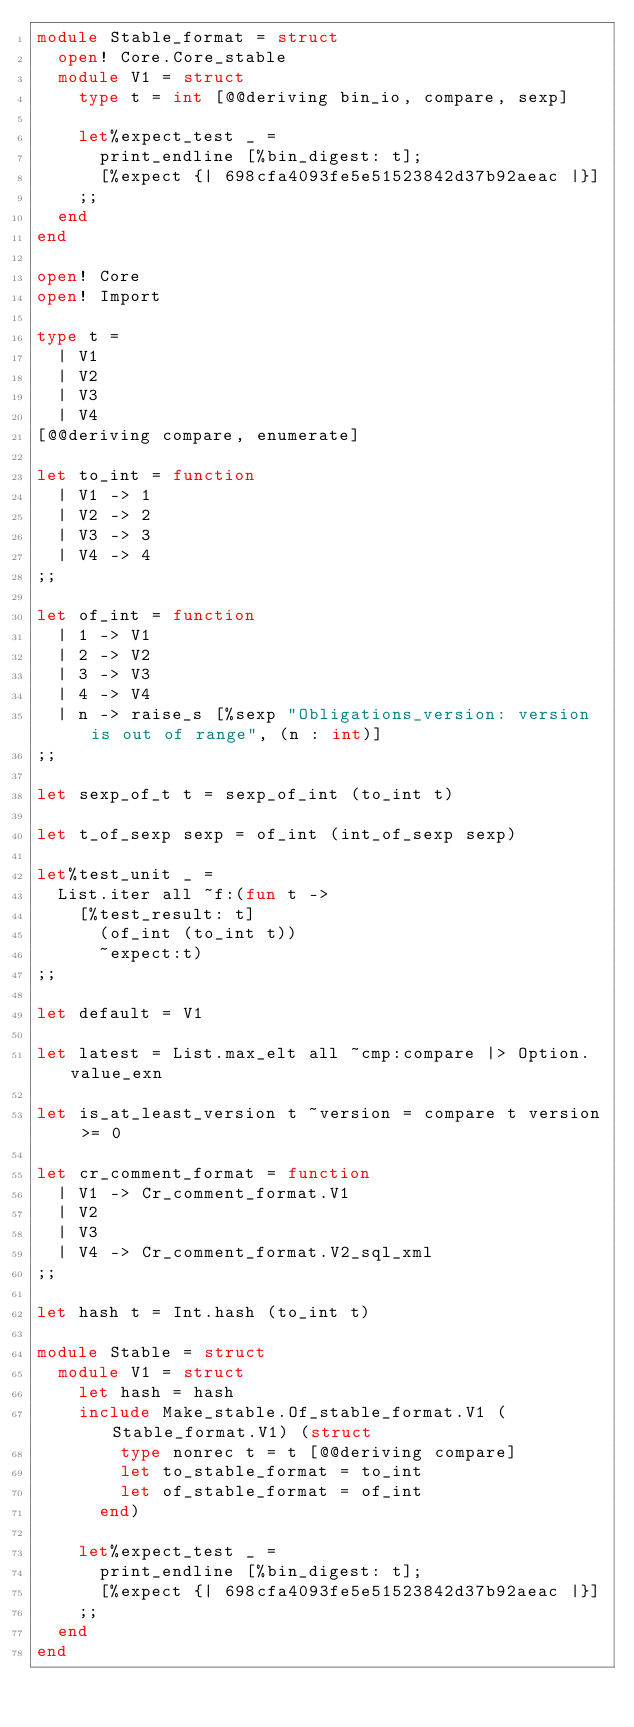Convert code to text. <code><loc_0><loc_0><loc_500><loc_500><_OCaml_>module Stable_format = struct
  open! Core.Core_stable
  module V1 = struct
    type t = int [@@deriving bin_io, compare, sexp]

    let%expect_test _ =
      print_endline [%bin_digest: t];
      [%expect {| 698cfa4093fe5e51523842d37b92aeac |}]
    ;;
  end
end

open! Core
open! Import

type t =
  | V1
  | V2
  | V3
  | V4
[@@deriving compare, enumerate]

let to_int = function
  | V1 -> 1
  | V2 -> 2
  | V3 -> 3
  | V4 -> 4
;;

let of_int = function
  | 1 -> V1
  | 2 -> V2
  | 3 -> V3
  | 4 -> V4
  | n -> raise_s [%sexp "Obligations_version: version is out of range", (n : int)]
;;

let sexp_of_t t = sexp_of_int (to_int t)

let t_of_sexp sexp = of_int (int_of_sexp sexp)

let%test_unit _ =
  List.iter all ~f:(fun t ->
    [%test_result: t]
      (of_int (to_int t))
      ~expect:t)
;;

let default = V1

let latest = List.max_elt all ~cmp:compare |> Option.value_exn

let is_at_least_version t ~version = compare t version >= 0

let cr_comment_format = function
  | V1 -> Cr_comment_format.V1
  | V2
  | V3
  | V4 -> Cr_comment_format.V2_sql_xml
;;

let hash t = Int.hash (to_int t)

module Stable = struct
  module V1 = struct
    let hash = hash
    include Make_stable.Of_stable_format.V1 (Stable_format.V1) (struct
        type nonrec t = t [@@deriving compare]
        let to_stable_format = to_int
        let of_stable_format = of_int
      end)

    let%expect_test _ =
      print_endline [%bin_digest: t];
      [%expect {| 698cfa4093fe5e51523842d37b92aeac |}]
    ;;
  end
end
</code> 